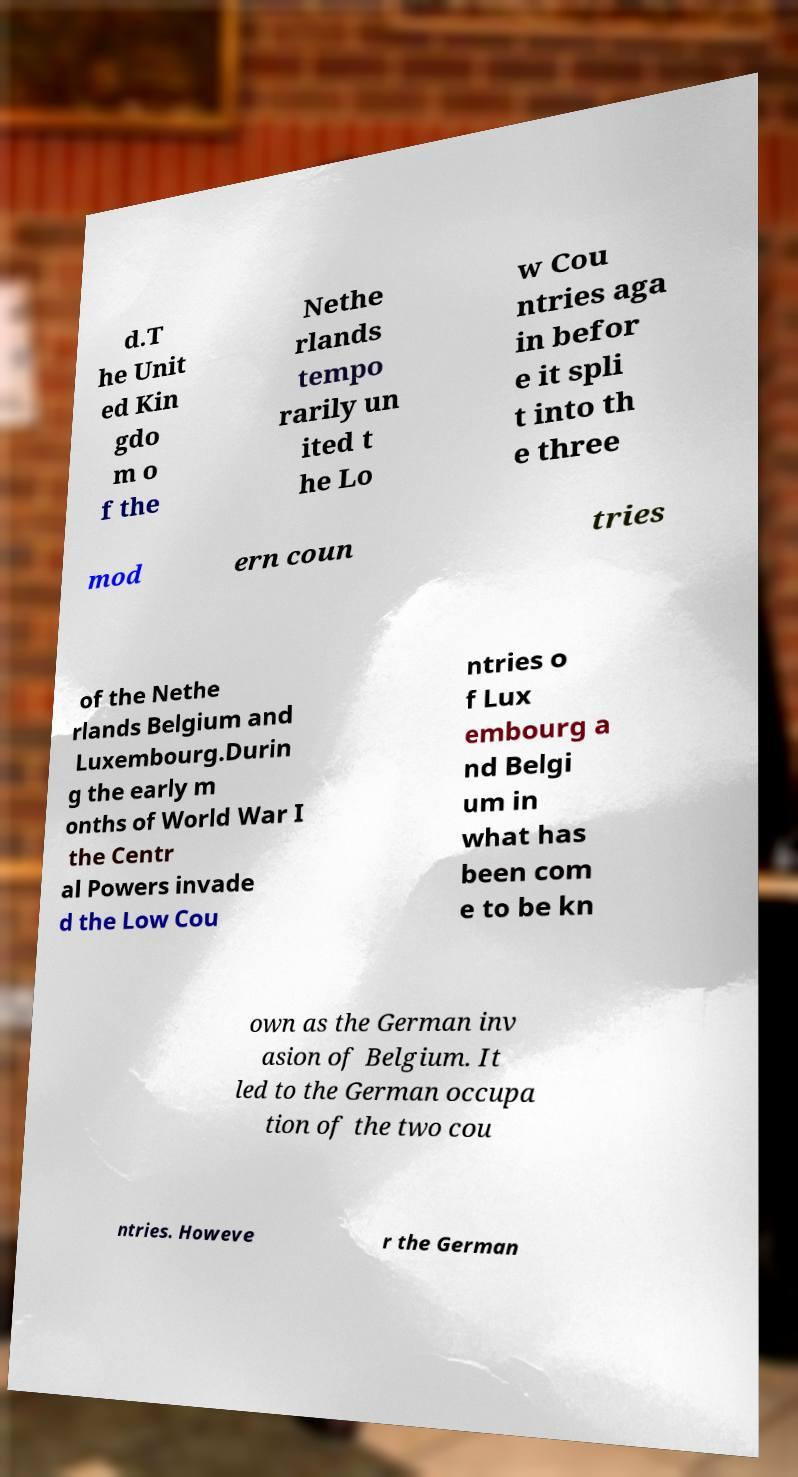I need the written content from this picture converted into text. Can you do that? d.T he Unit ed Kin gdo m o f the Nethe rlands tempo rarily un ited t he Lo w Cou ntries aga in befor e it spli t into th e three mod ern coun tries of the Nethe rlands Belgium and Luxembourg.Durin g the early m onths of World War I the Centr al Powers invade d the Low Cou ntries o f Lux embourg a nd Belgi um in what has been com e to be kn own as the German inv asion of Belgium. It led to the German occupa tion of the two cou ntries. Howeve r the German 